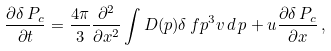<formula> <loc_0><loc_0><loc_500><loc_500>\frac { \partial \delta \, P _ { c } } { \partial t } = \frac { 4 \pi } { 3 } \frac { \partial ^ { 2 } } { \partial x ^ { 2 } } \int D ( p ) \delta \, f p ^ { 3 } v \, d \, p + u \frac { \partial \delta \, P _ { c } } { \partial x } \, ,</formula> 